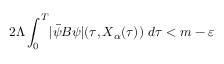<formula> <loc_0><loc_0><loc_500><loc_500>2 \Lambda \int _ { 0 } ^ { T } | \ B a r { \psi } B \psi | ( \tau , X _ { \alpha } ( \tau ) ) \ d \tau < m - \varepsilon</formula> 